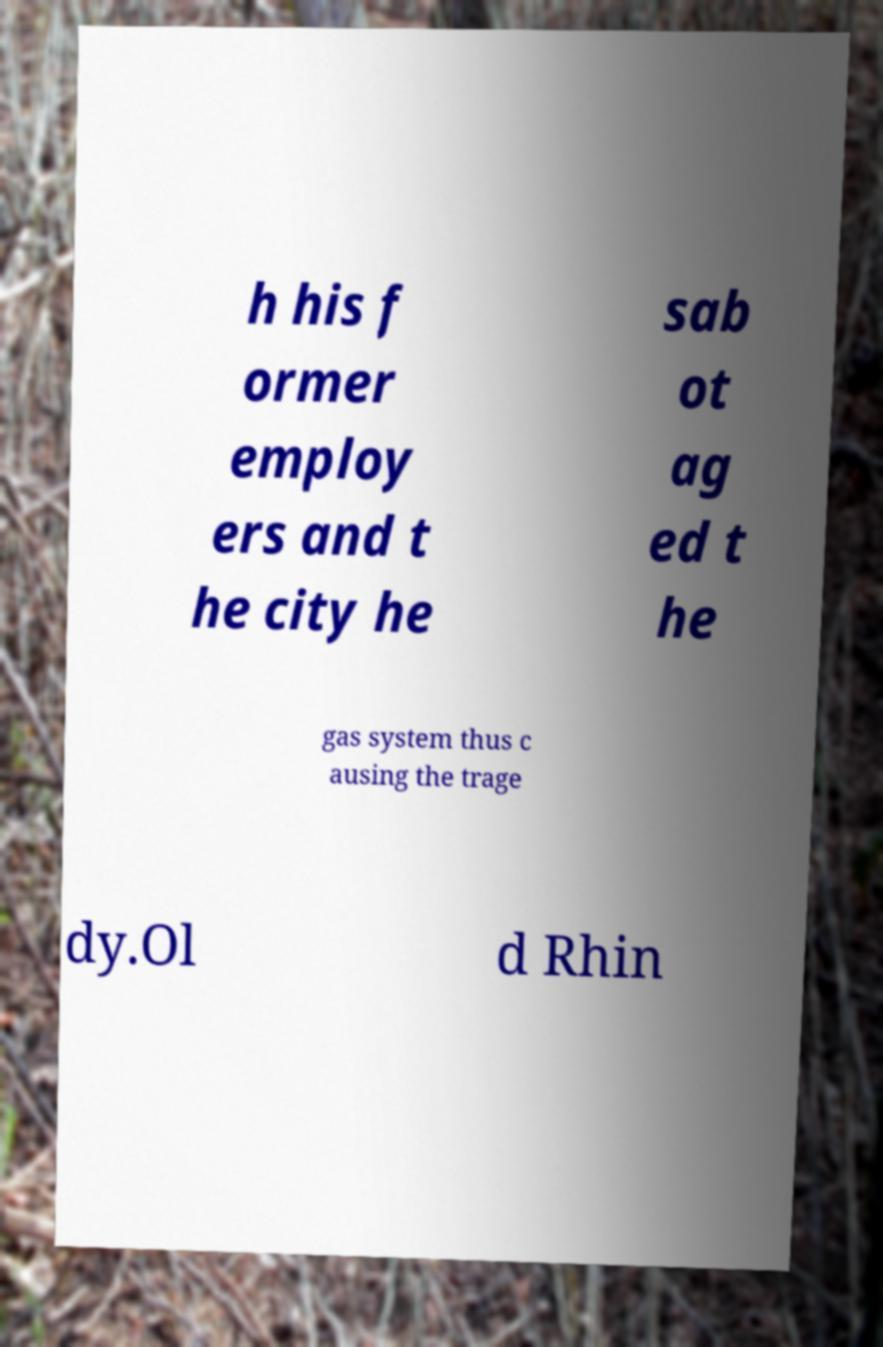Could you assist in decoding the text presented in this image and type it out clearly? h his f ormer employ ers and t he city he sab ot ag ed t he gas system thus c ausing the trage dy.Ol d Rhin 